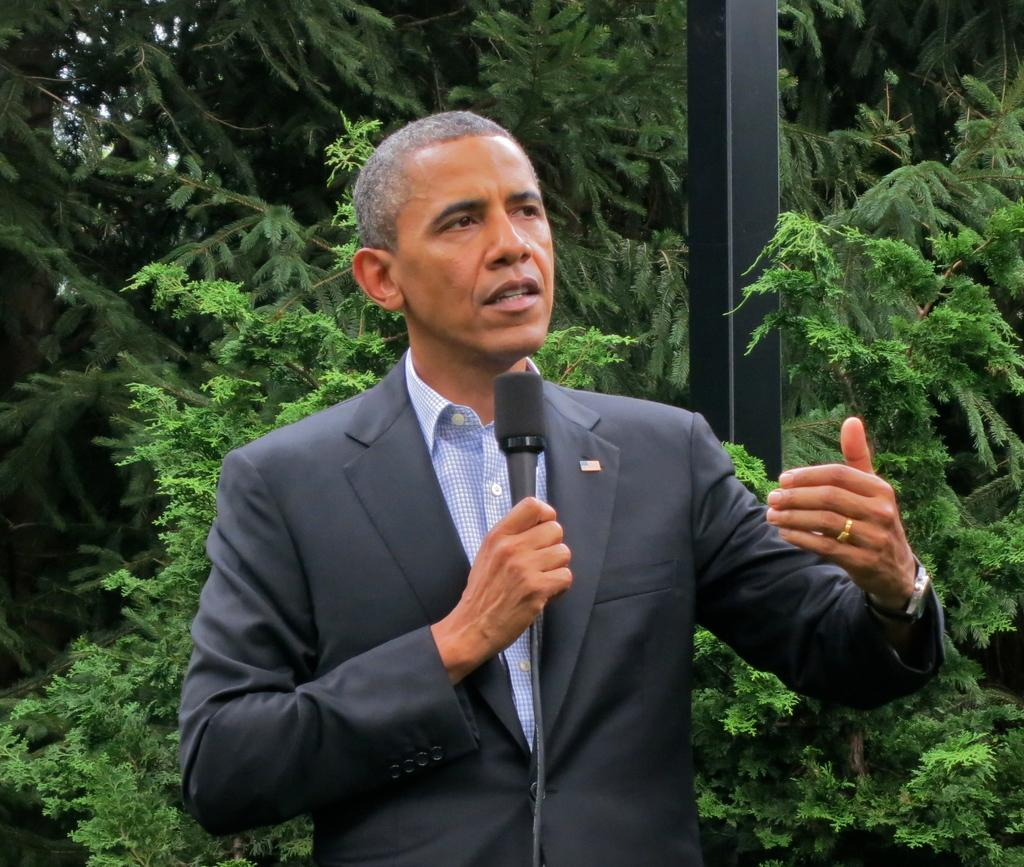What is the main subject of the image? There is a person standing in the middle of the image. What is the person holding in the image? The person is holding a microphone. What type of vegetation can be seen behind the person? There are trees behind the person. Can you describe any other objects or structures in the image? There is a pole visible in the image. What type of operation is being performed on the person in the image? There is no operation being performed on the person in the image. How many lights can be seen illuminating the person in the image? There is no mention of lights in the image, so we cannot determine how many lights are present. 